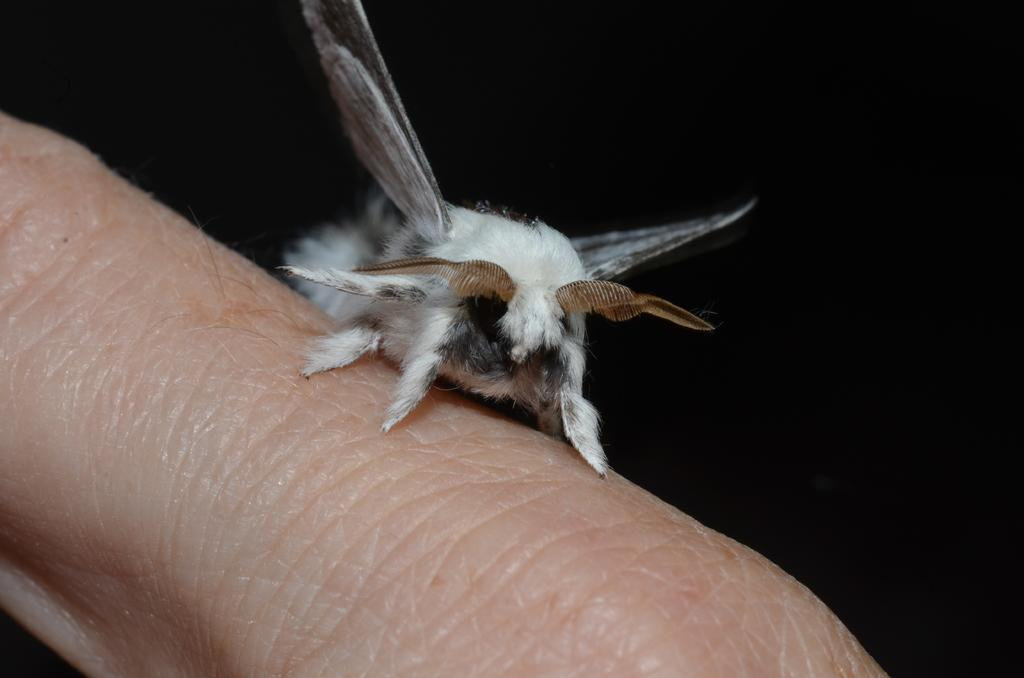What type of creature is in the image? There is an insect in the image. What colors can be seen on the insect? The insect has white, black, and brown colors. Where is the insect located in the image? The insect is on a human finger. What is the color of the background in the image? The background of the image is black. What type of teaching method is being demonstrated in the image? There is no teaching method or test present in the image; it features an insect on a human finger with a black background. Is the insect wearing a scarf in the image? There is no scarf present in the image; the insect has white, black, and brown colors on its body. 